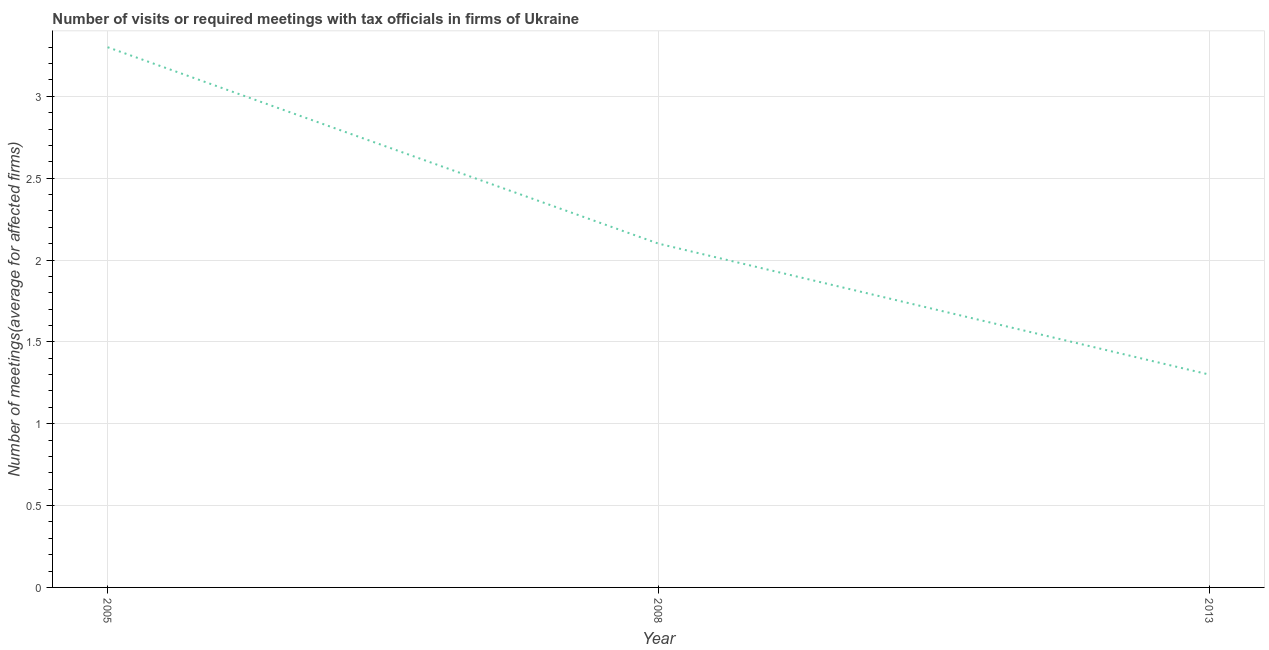What is the number of required meetings with tax officials in 2008?
Your answer should be very brief. 2.1. Across all years, what is the maximum number of required meetings with tax officials?
Your answer should be very brief. 3.3. In which year was the number of required meetings with tax officials maximum?
Provide a succinct answer. 2005. What is the sum of the number of required meetings with tax officials?
Provide a succinct answer. 6.7. What is the difference between the number of required meetings with tax officials in 2005 and 2008?
Provide a succinct answer. 1.2. What is the average number of required meetings with tax officials per year?
Your answer should be compact. 2.23. In how many years, is the number of required meetings with tax officials greater than 1.5 ?
Your answer should be very brief. 2. What is the ratio of the number of required meetings with tax officials in 2008 to that in 2013?
Provide a short and direct response. 1.62. Is the number of required meetings with tax officials in 2005 less than that in 2008?
Ensure brevity in your answer.  No. What is the difference between the highest and the second highest number of required meetings with tax officials?
Your answer should be very brief. 1.2. What is the difference between the highest and the lowest number of required meetings with tax officials?
Your answer should be very brief. 2. What is the title of the graph?
Your answer should be compact. Number of visits or required meetings with tax officials in firms of Ukraine. What is the label or title of the Y-axis?
Offer a terse response. Number of meetings(average for affected firms). What is the difference between the Number of meetings(average for affected firms) in 2008 and 2013?
Ensure brevity in your answer.  0.8. What is the ratio of the Number of meetings(average for affected firms) in 2005 to that in 2008?
Your answer should be compact. 1.57. What is the ratio of the Number of meetings(average for affected firms) in 2005 to that in 2013?
Keep it short and to the point. 2.54. What is the ratio of the Number of meetings(average for affected firms) in 2008 to that in 2013?
Offer a very short reply. 1.61. 